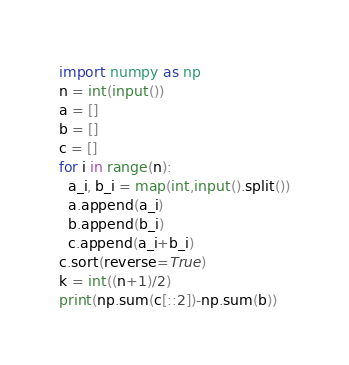<code> <loc_0><loc_0><loc_500><loc_500><_Python_>import numpy as np
n = int(input())
a = []
b = []
c = []
for i in range(n):
  a_i, b_i = map(int,input().split())
  a.append(a_i)
  b.append(b_i)
  c.append(a_i+b_i)
c.sort(reverse=True)
k = int((n+1)/2)
print(np.sum(c[::2])-np.sum(b))</code> 